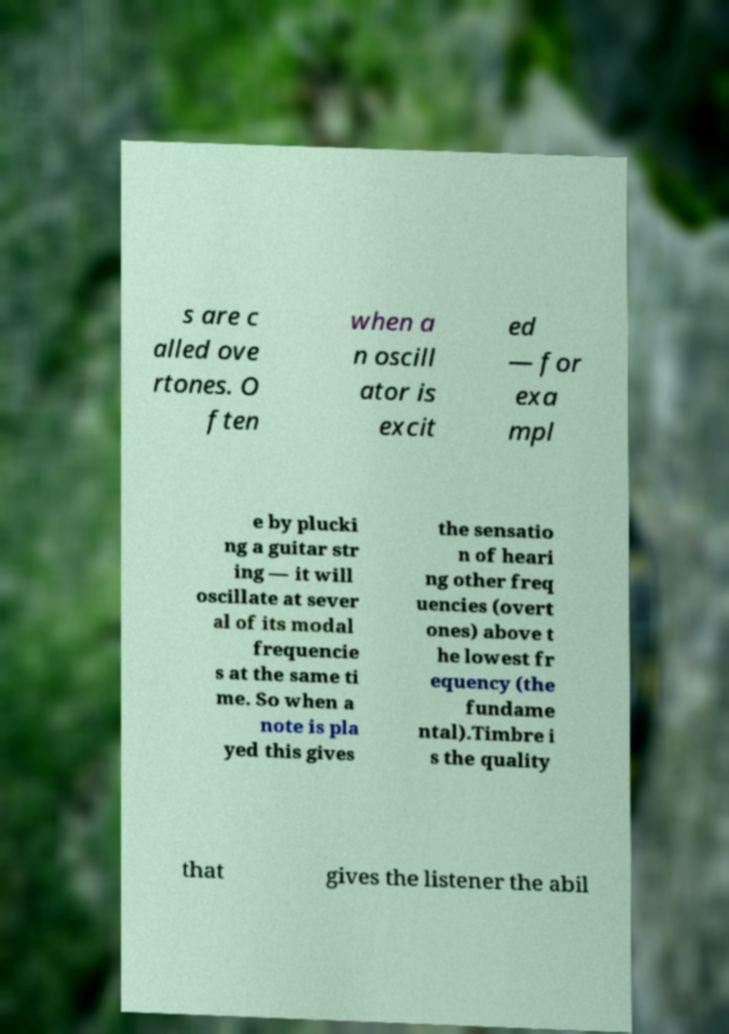Please read and relay the text visible in this image. What does it say? s are c alled ove rtones. O ften when a n oscill ator is excit ed — for exa mpl e by plucki ng a guitar str ing — it will oscillate at sever al of its modal frequencie s at the same ti me. So when a note is pla yed this gives the sensatio n of heari ng other freq uencies (overt ones) above t he lowest fr equency (the fundame ntal).Timbre i s the quality that gives the listener the abil 